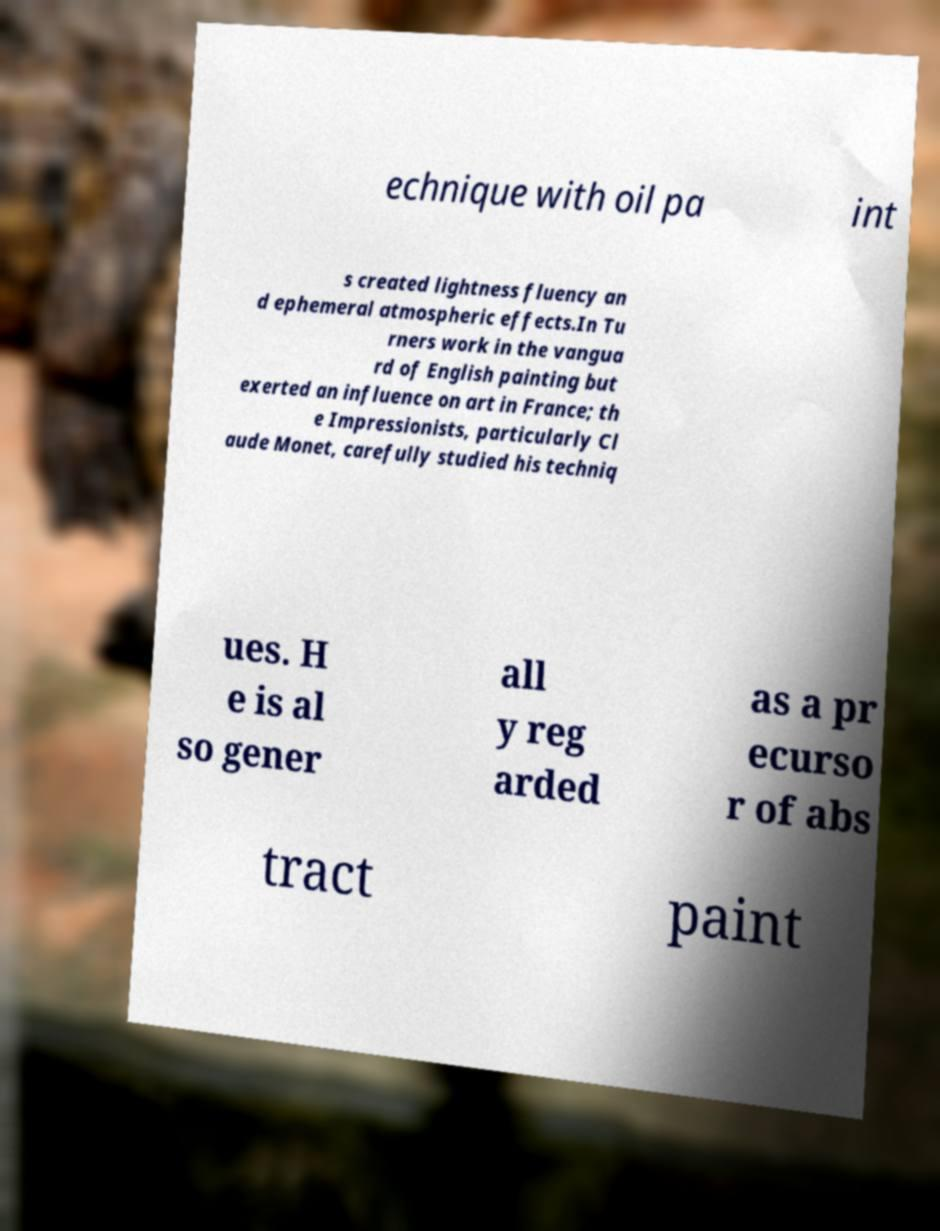Could you extract and type out the text from this image? echnique with oil pa int s created lightness fluency an d ephemeral atmospheric effects.In Tu rners work in the vangua rd of English painting but exerted an influence on art in France; th e Impressionists, particularly Cl aude Monet, carefully studied his techniq ues. H e is al so gener all y reg arded as a pr ecurso r of abs tract paint 